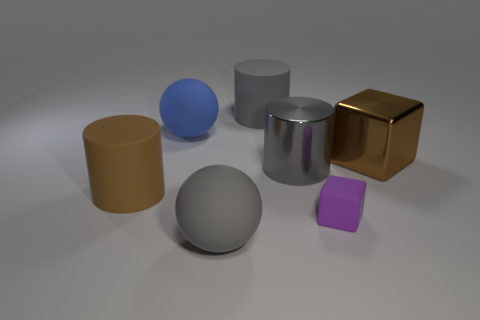Subtract all red balls. How many gray cylinders are left? 2 Subtract all large metallic cylinders. How many cylinders are left? 2 Add 3 matte cylinders. How many objects exist? 10 Subtract all purple cylinders. Subtract all gray blocks. How many cylinders are left? 3 Subtract all spheres. How many objects are left? 5 Subtract all small green objects. Subtract all large gray shiny cylinders. How many objects are left? 6 Add 2 big gray things. How many big gray things are left? 5 Add 2 tiny red metal spheres. How many tiny red metal spheres exist? 2 Subtract 0 green cubes. How many objects are left? 7 